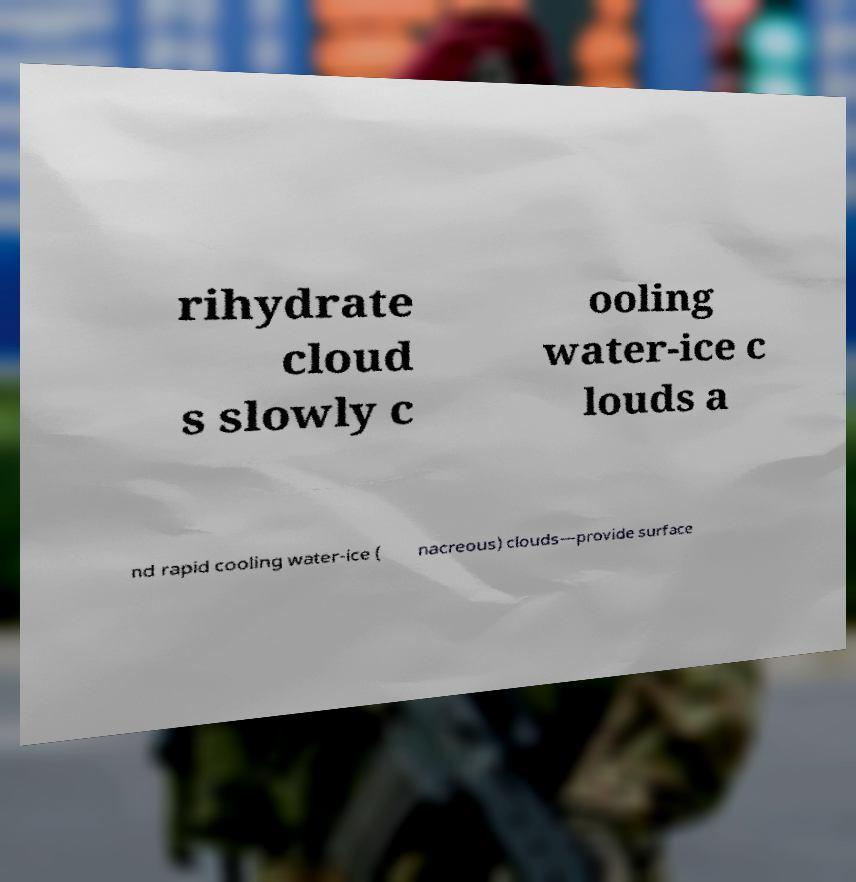What messages or text are displayed in this image? I need them in a readable, typed format. rihydrate cloud s slowly c ooling water-ice c louds a nd rapid cooling water-ice ( nacreous) clouds—provide surface 